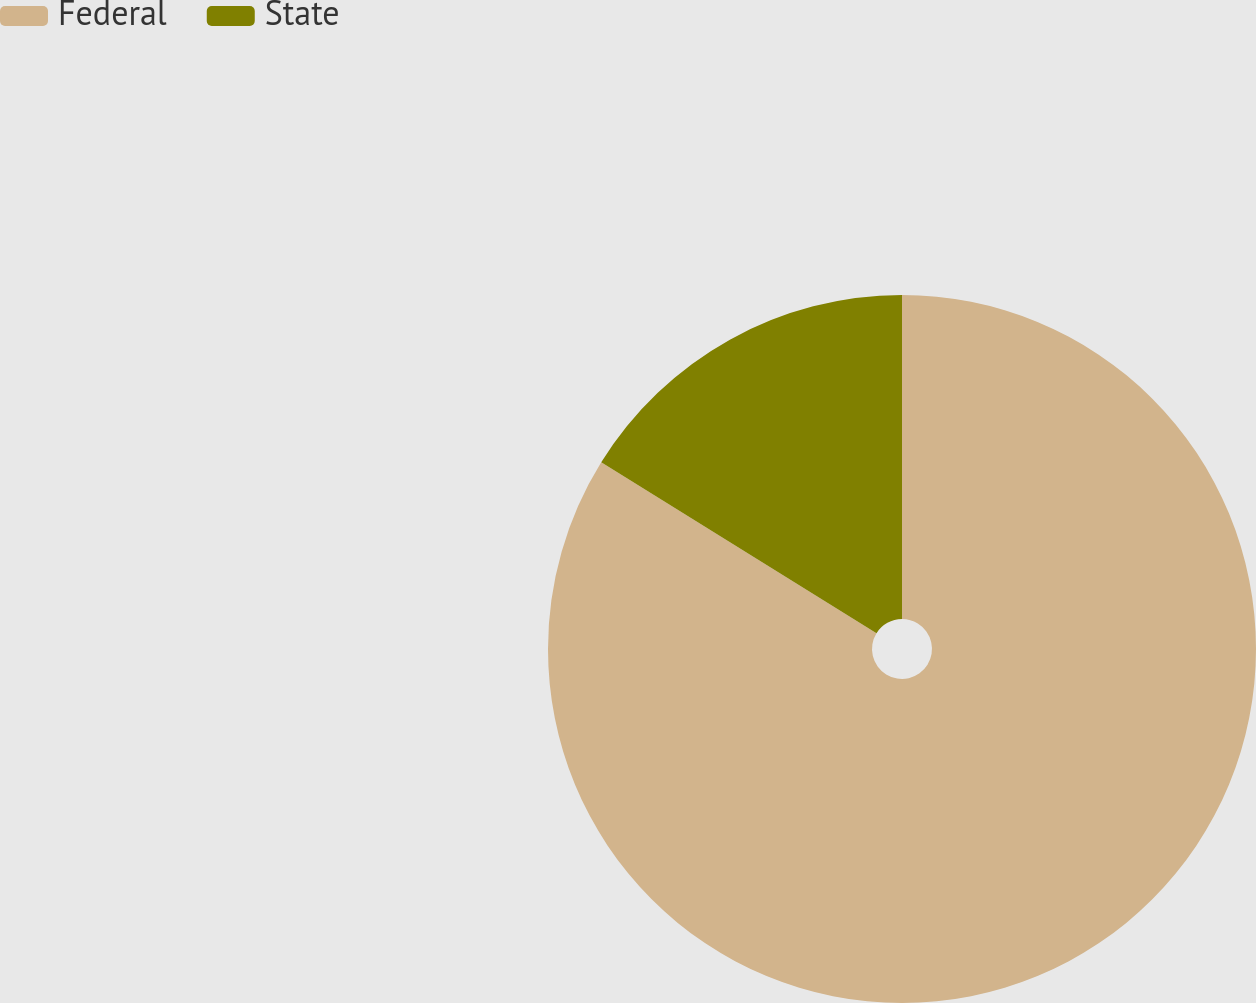Convert chart to OTSL. <chart><loc_0><loc_0><loc_500><loc_500><pie_chart><fcel>Federal<fcel>State<nl><fcel>83.84%<fcel>16.16%<nl></chart> 